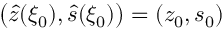<formula> <loc_0><loc_0><loc_500><loc_500>\left ( \hat { z } ( \xi _ { 0 } ) , \hat { s } ( \xi _ { 0 } ) \right ) = ( z _ { 0 } , s _ { 0 } )</formula> 